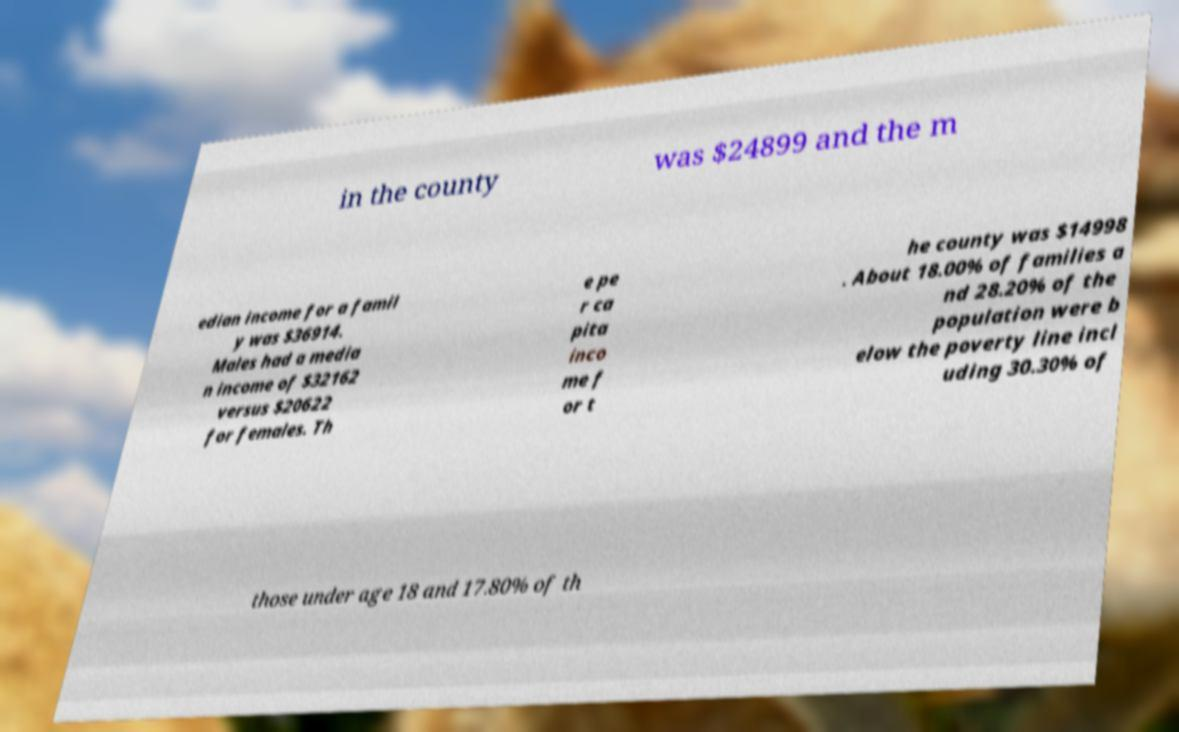Please identify and transcribe the text found in this image. in the county was $24899 and the m edian income for a famil y was $36914. Males had a media n income of $32162 versus $20622 for females. Th e pe r ca pita inco me f or t he county was $14998 . About 18.00% of families a nd 28.20% of the population were b elow the poverty line incl uding 30.30% of those under age 18 and 17.80% of th 